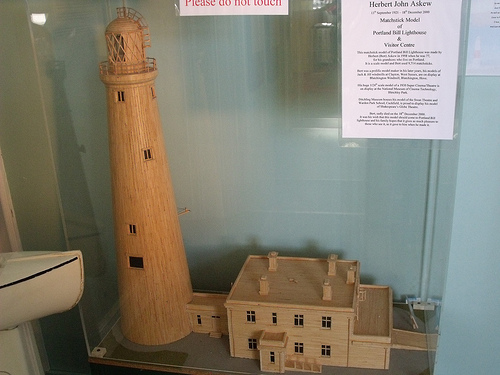<image>
Is there a house behind the glass? Yes. From this viewpoint, the house is positioned behind the glass, with the glass partially or fully occluding the house. Where is the boat in relation to the lighthouse? Is it in front of the lighthouse? Yes. The boat is positioned in front of the lighthouse, appearing closer to the camera viewpoint. 